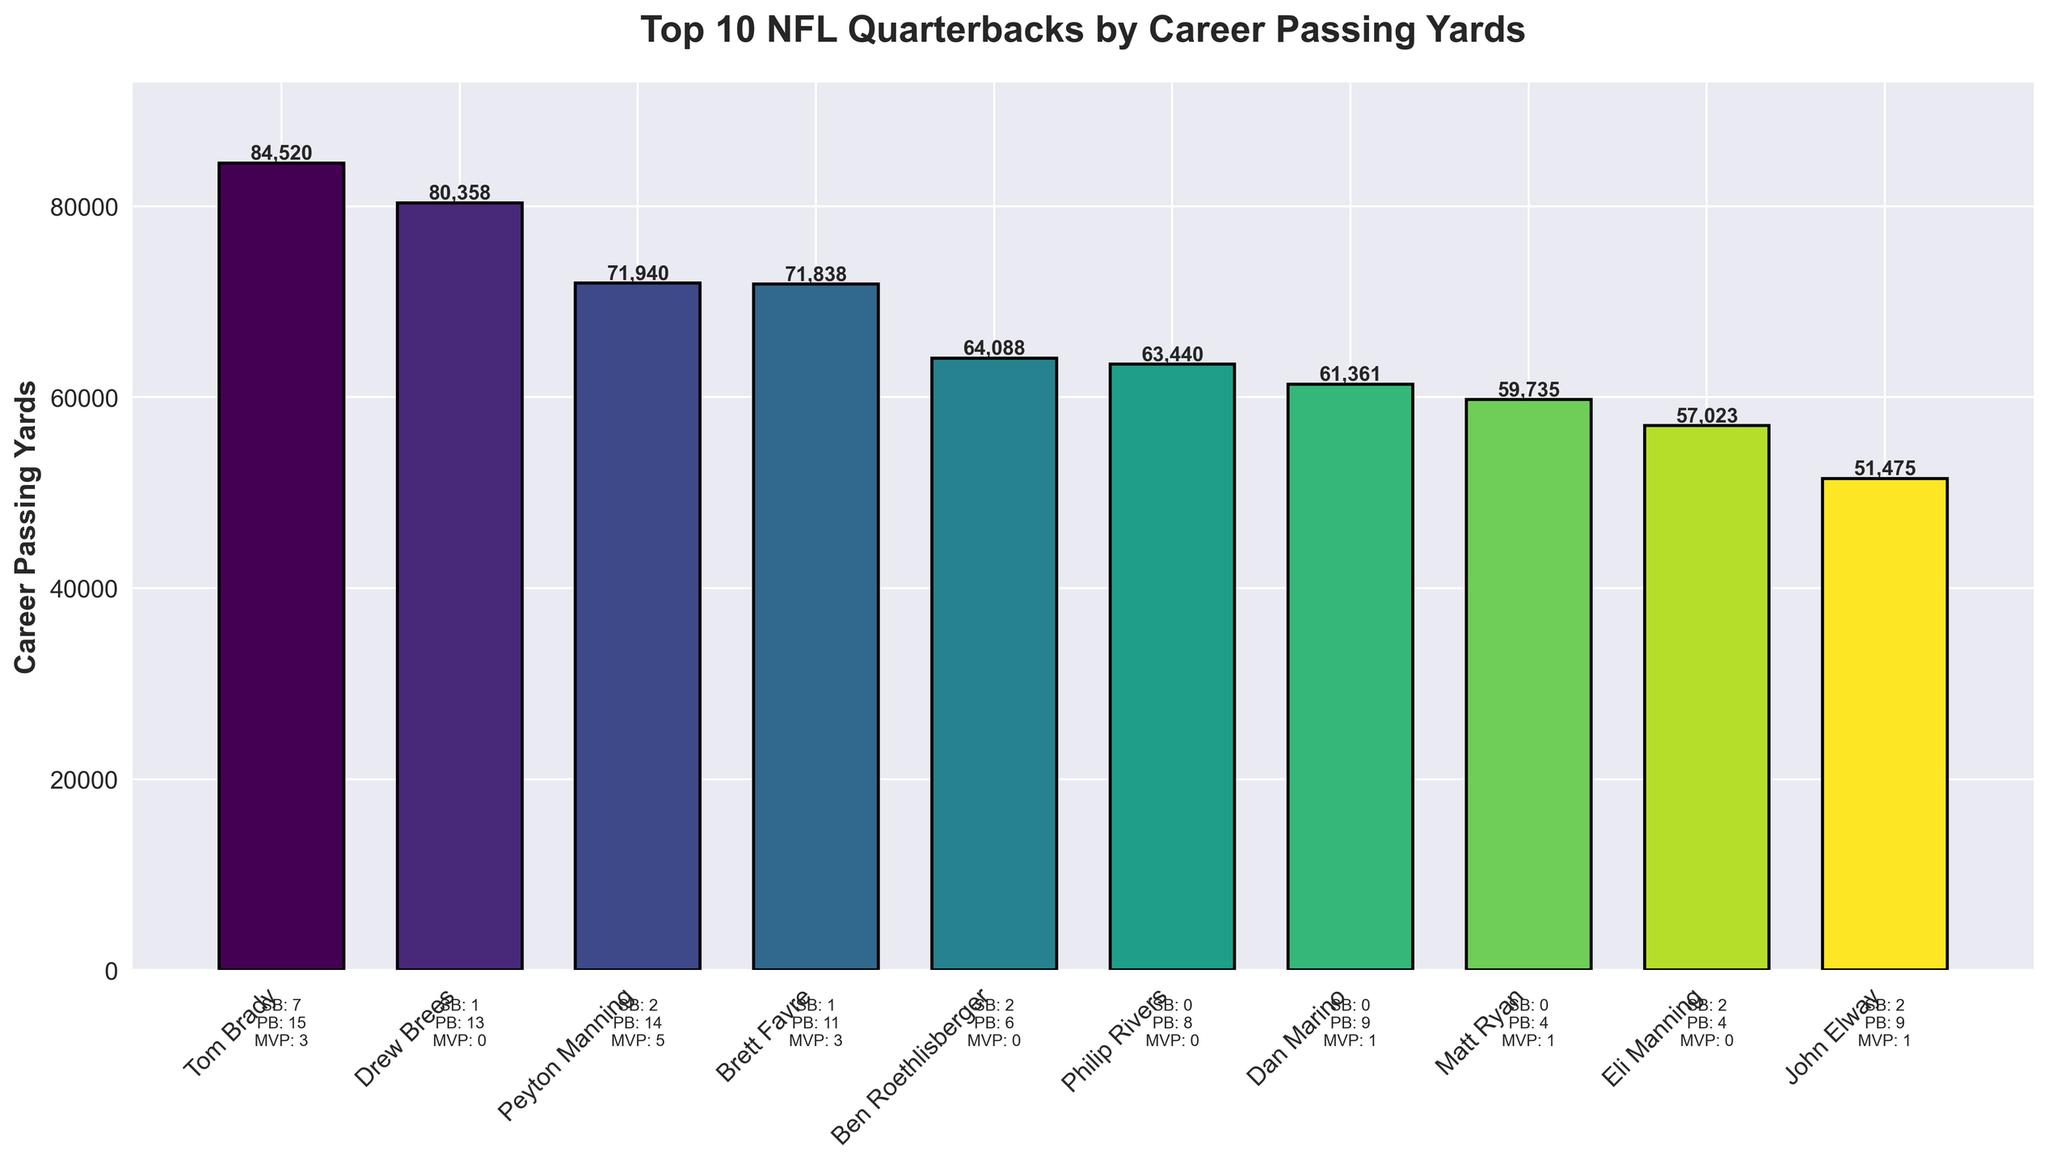Which quarterback has the highest career passing yards? By examining the heights of the bars, we can see that Tom Brady's bar is the tallest, indicating that he has the highest career passing yards.
Answer: Tom Brady How many Super Bowl wins does the quarterback with the lowest career passing yards have? The bar for John Elway is the shortest, representing the lowest career passing yards. By looking at the labels beneath the bar, we can confirm that he has 2 Super Bowl wins.
Answer: 2 What is the difference in career passing yards between Drew Brees and Brett Favre? The height of Drew Brees' bar corresponds to 80,358 yards, and Brett Favre's to 71,838 yards. The difference is calculated as 80,358 - 71,838.
Answer: 8,520 yards Which quarterback appears fourth when sorted by career passing yards in descending order? When sorted by height, the fourth highest bar corresponds to Brett Favre.
Answer: Brett Favre How many quarterbacks have won exactly 2 Super Bowl titles? By examining the "SB" labels under each bar, we observe that Peyton Manning, Ben Roethlisberger, and Eli Manning each have 2 Super Bowl wins.
Answer: 3 Which quarterback has more Pro Bowl selections than Dan Marino but fewer than Peyton Manning? Dan Marino has 9 Pro Bowl selections, indicated under his bar, while Peyton Manning has 14. The quarterback with selections between these two is Drew Brees with 13.
Answer: Drew Brees What is the sum of career passing yards for the quarterbacks with no Super Bowl wins? The quarterbacks with no Super Bowl wins (SB: 0) are Philip Rivers, Dan Marino, and Matt Ryan. Summing their career passing yards: 63,440 + 61,361 + 59,735.
Answer: 184,536 yards Which quarterback's bar is visually closest in height to Ben Roethlisberger's? By comparing the heights of the bars, we observe that Philip Rivers' bar is very close in height to Ben Roethlisberger’s bar.
Answer: Philip Rivers What is the average number of MVP Awards among all listed quarterbacks? Adding up the MVP Awards and dividing by the number of quarterbacks: (3 + 0 + 5 + 3 + 0 + 0 + 1 + 1 + 0 + 1) / 10 = 14 / 10.
Answer: 1.4 How many quarterbacks have been selected to the Pro Bowl at least 10 times? By examining the "PB" labels, quarterbacks with at least 10 selections are Tom Brady (15), Drew Brees (13), Peyton Manning (14), and Brett Favre (11).
Answer: 4 